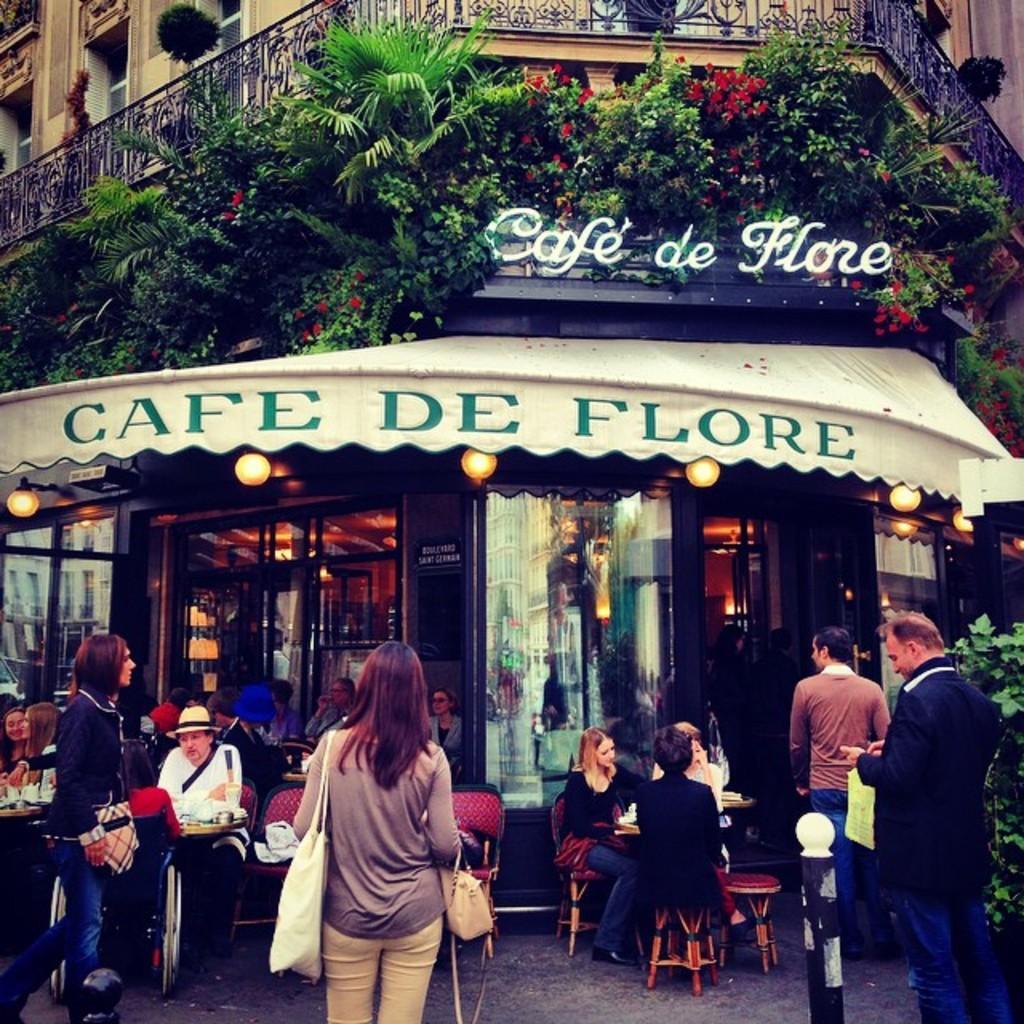Please provide a concise description of this image. In the picture we can see a building and a railing to it with some windows to the building and under it we can see some plants and under it we can see a shop with a name of the shop is cafe de flore and near the shop we can see some people are sitting on the chairs and some people are standing wearing a hand bag. 